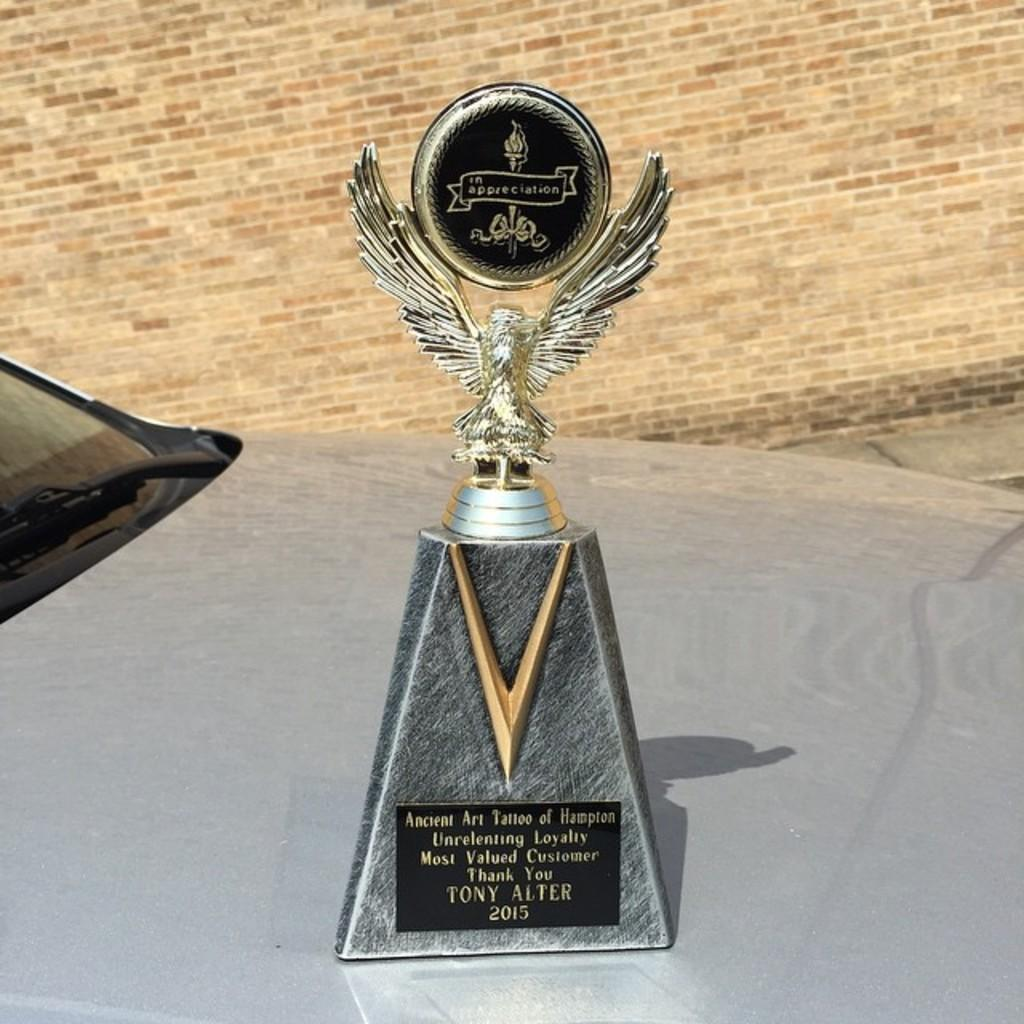<image>
Share a concise interpretation of the image provided. a trophy with an eagle for TONY ALTER 2015 sits on a car hood 